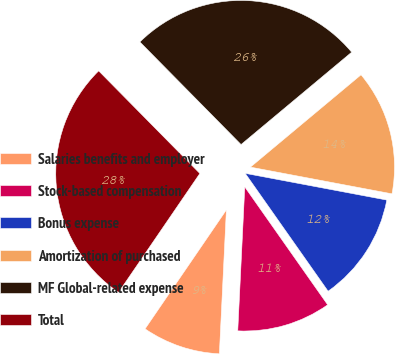<chart> <loc_0><loc_0><loc_500><loc_500><pie_chart><fcel>Salaries benefits and employer<fcel>Stock-based compensation<fcel>Bonus expense<fcel>Amortization of purchased<fcel>MF Global-related expense<fcel>Total<nl><fcel>8.77%<fcel>10.53%<fcel>12.28%<fcel>14.04%<fcel>26.32%<fcel>28.07%<nl></chart> 